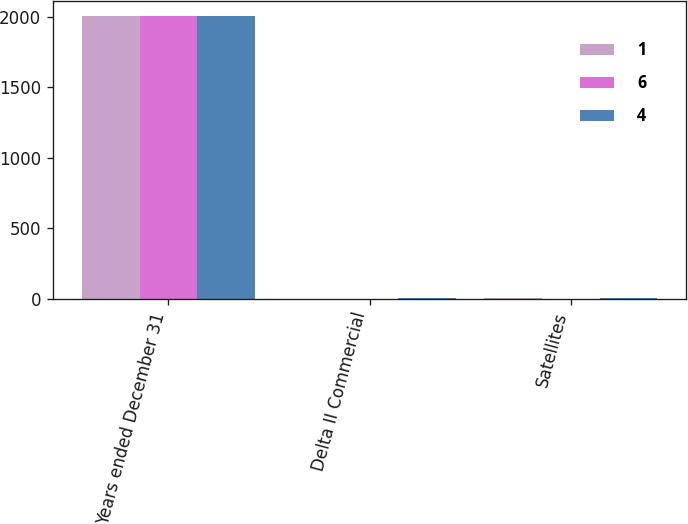<chart> <loc_0><loc_0><loc_500><loc_500><stacked_bar_chart><ecel><fcel>Years ended December 31<fcel>Delta II Commercial<fcel>Satellites<nl><fcel>1<fcel>2009<fcel>1<fcel>6<nl><fcel>6<fcel>2008<fcel>2<fcel>1<nl><fcel>4<fcel>2007<fcel>3<fcel>4<nl></chart> 